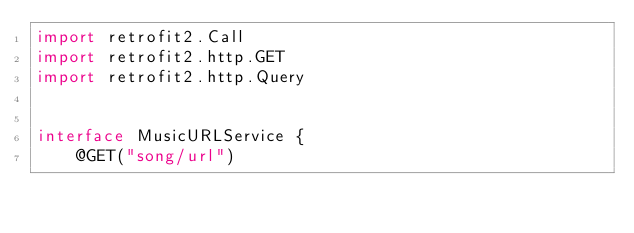Convert code to text. <code><loc_0><loc_0><loc_500><loc_500><_Kotlin_>import retrofit2.Call
import retrofit2.http.GET
import retrofit2.http.Query


interface MusicURLService {
    @GET("song/url")</code> 